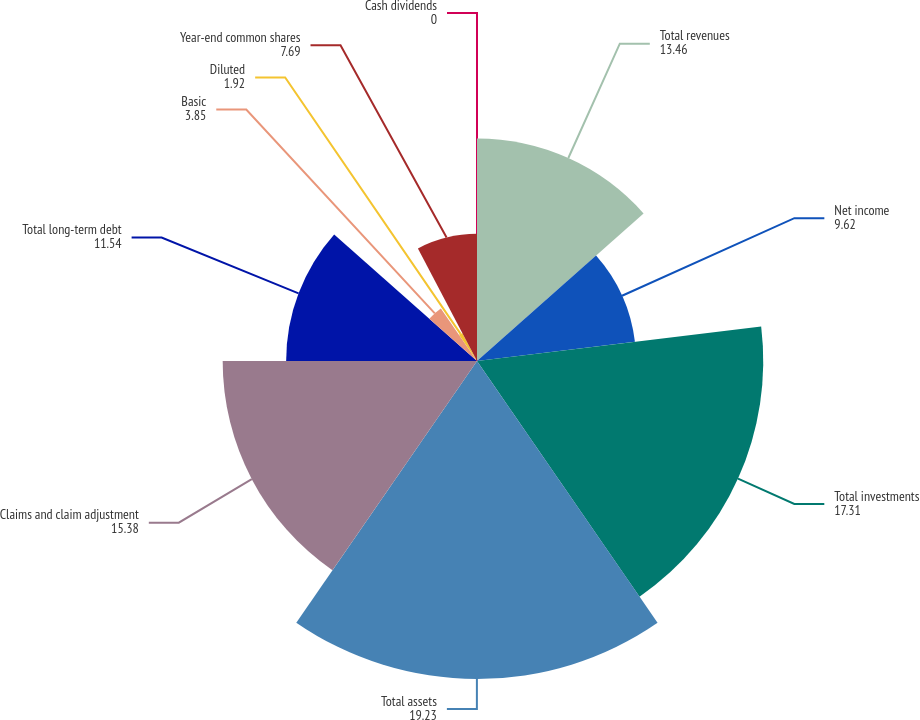<chart> <loc_0><loc_0><loc_500><loc_500><pie_chart><fcel>Total revenues<fcel>Net income<fcel>Total investments<fcel>Total assets<fcel>Claims and claim adjustment<fcel>Total long-term debt<fcel>Basic<fcel>Diluted<fcel>Year-end common shares<fcel>Cash dividends<nl><fcel>13.46%<fcel>9.62%<fcel>17.31%<fcel>19.23%<fcel>15.38%<fcel>11.54%<fcel>3.85%<fcel>1.92%<fcel>7.69%<fcel>0.0%<nl></chart> 